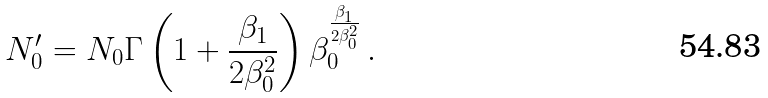Convert formula to latex. <formula><loc_0><loc_0><loc_500><loc_500>N _ { 0 } ^ { \prime } = N _ { 0 } \Gamma \left ( 1 + \frac { \beta _ { 1 } } { 2 \beta _ { 0 } ^ { 2 } } \right ) \beta _ { 0 } ^ { \frac { \beta _ { 1 } } { 2 \beta _ { 0 } ^ { 2 } } } \, .</formula> 